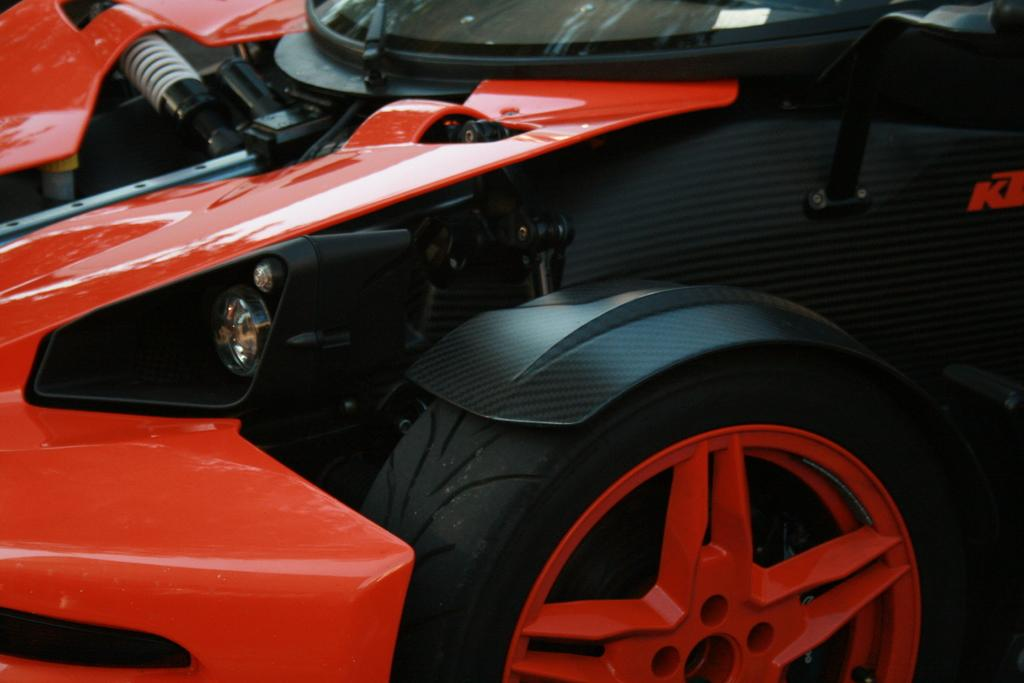What is the main subject in the image? There is a vehicle in the image. How does the vehicle compare to a drug in terms of effectiveness? The image does not provide any information about drugs or their effectiveness, so it is not possible to make a comparison between the vehicle and a drug. 